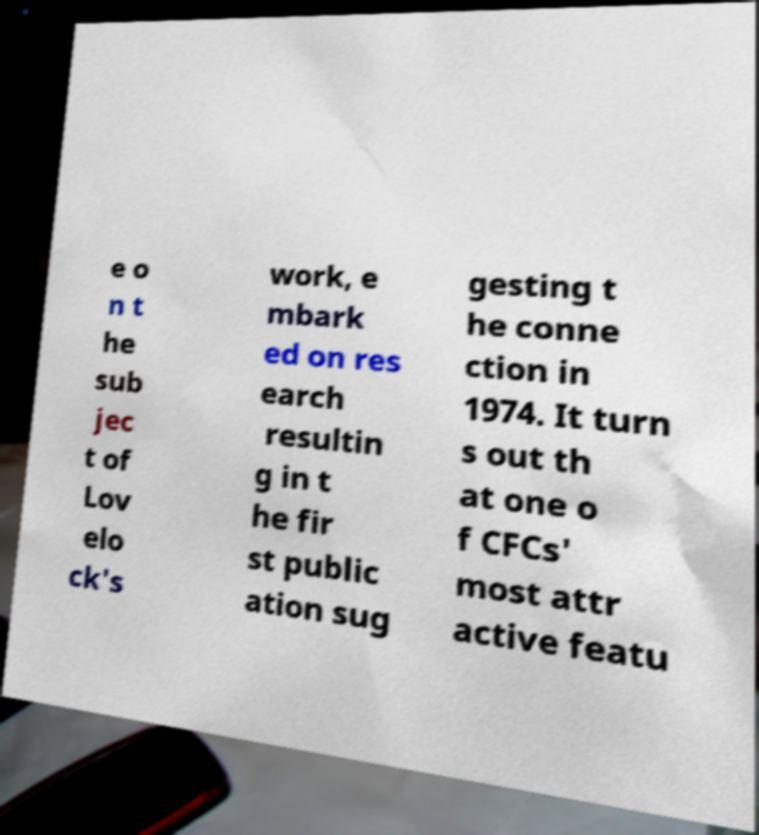For documentation purposes, I need the text within this image transcribed. Could you provide that? e o n t he sub jec t of Lov elo ck's work, e mbark ed on res earch resultin g in t he fir st public ation sug gesting t he conne ction in 1974. It turn s out th at one o f CFCs' most attr active featu 